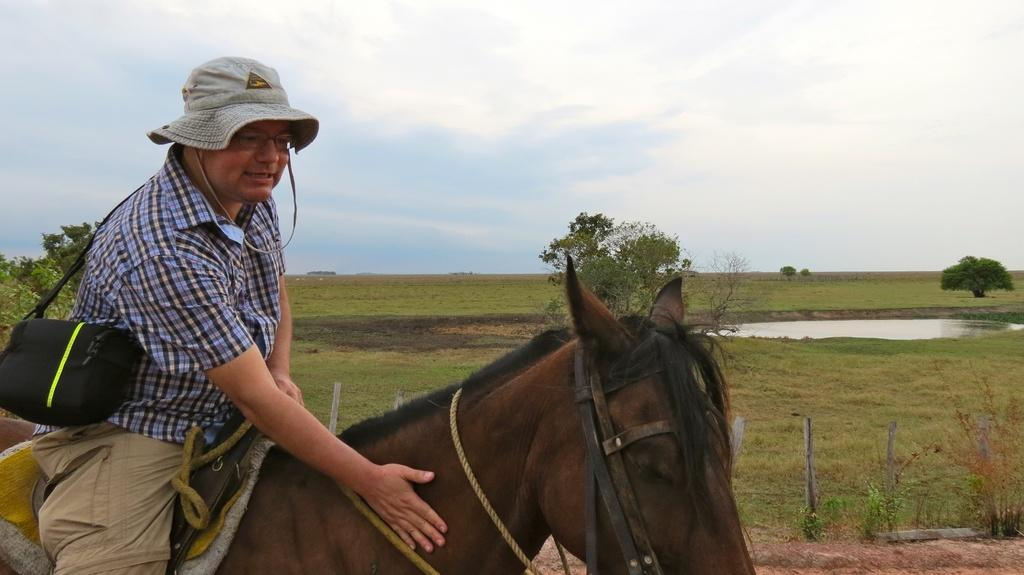What is the main subject of the image? The main subject of the image is a man. What is the man doing in the image? The man is sitting on a horse in the image. What is the man wearing on his head? The man is wearing a hat in the image. What can be seen in the background of the image? There are trees, water, and the sky visible in the background of the image. What is the rate of plastic consumption in the image? There is no mention of plastic or its consumption in the image, so it is impossible to determine a rate. 